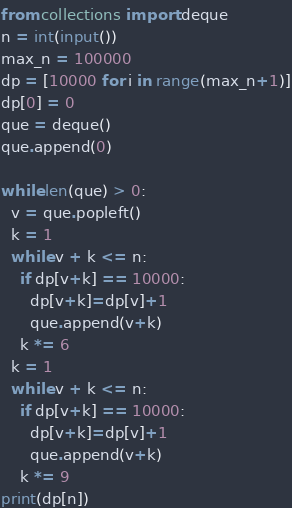Convert code to text. <code><loc_0><loc_0><loc_500><loc_500><_Python_>from collections import deque
n = int(input())
max_n = 100000
dp = [10000 for i in range(max_n+1)]
dp[0] = 0
que = deque()
que.append(0)

while len(que) > 0:
  v = que.popleft()
  k = 1
  while v + k <= n:
    if dp[v+k] == 10000:
      dp[v+k]=dp[v]+1
      que.append(v+k)
    k *= 6
  k = 1
  while v + k <= n:
    if dp[v+k] == 10000:
      dp[v+k]=dp[v]+1
      que.append(v+k)
    k *= 9
print(dp[n])</code> 